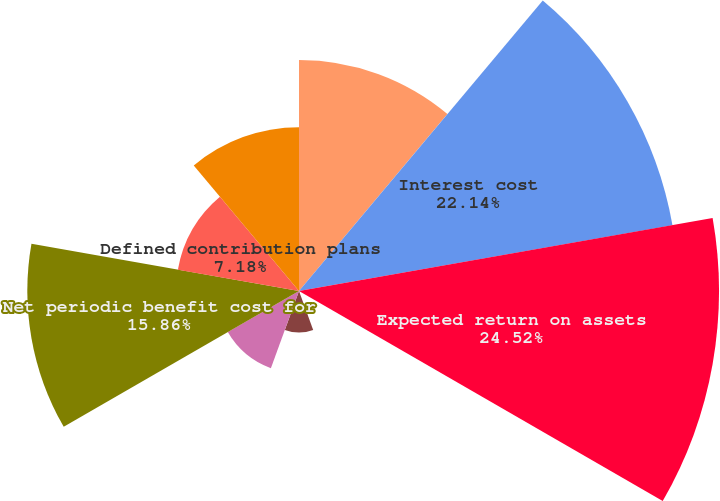Convert chart. <chart><loc_0><loc_0><loc_500><loc_500><pie_chart><fcel>Service cost<fcel>Interest cost<fcel>Expected return on assets<fcel>Transition asset<fcel>Prior service cost<fcel>Unrecognized net loss<fcel>Net periodic benefit cost for<fcel>Defined contribution plans<fcel>Net periodic benefit cost<nl><fcel>13.48%<fcel>22.14%<fcel>24.52%<fcel>0.04%<fcel>2.42%<fcel>4.8%<fcel>15.86%<fcel>7.18%<fcel>9.56%<nl></chart> 